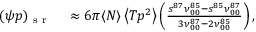Convert formula to latex. <formula><loc_0><loc_0><loc_500><loc_500>\begin{array} { r l } { ( \psi p ) _ { s r } } & \approx 6 \pi \langle N \rangle \left \langle T p ^ { 2 } \right \rangle \left ( \frac { s ^ { 8 7 } \nu _ { 0 0 } ^ { 8 5 } - s ^ { 8 5 } \nu _ { 0 0 } ^ { 8 7 } } { 3 \nu _ { 0 0 } ^ { 8 7 } - 2 \nu _ { 0 0 } ^ { 8 5 } } \right ) , } \end{array}</formula> 